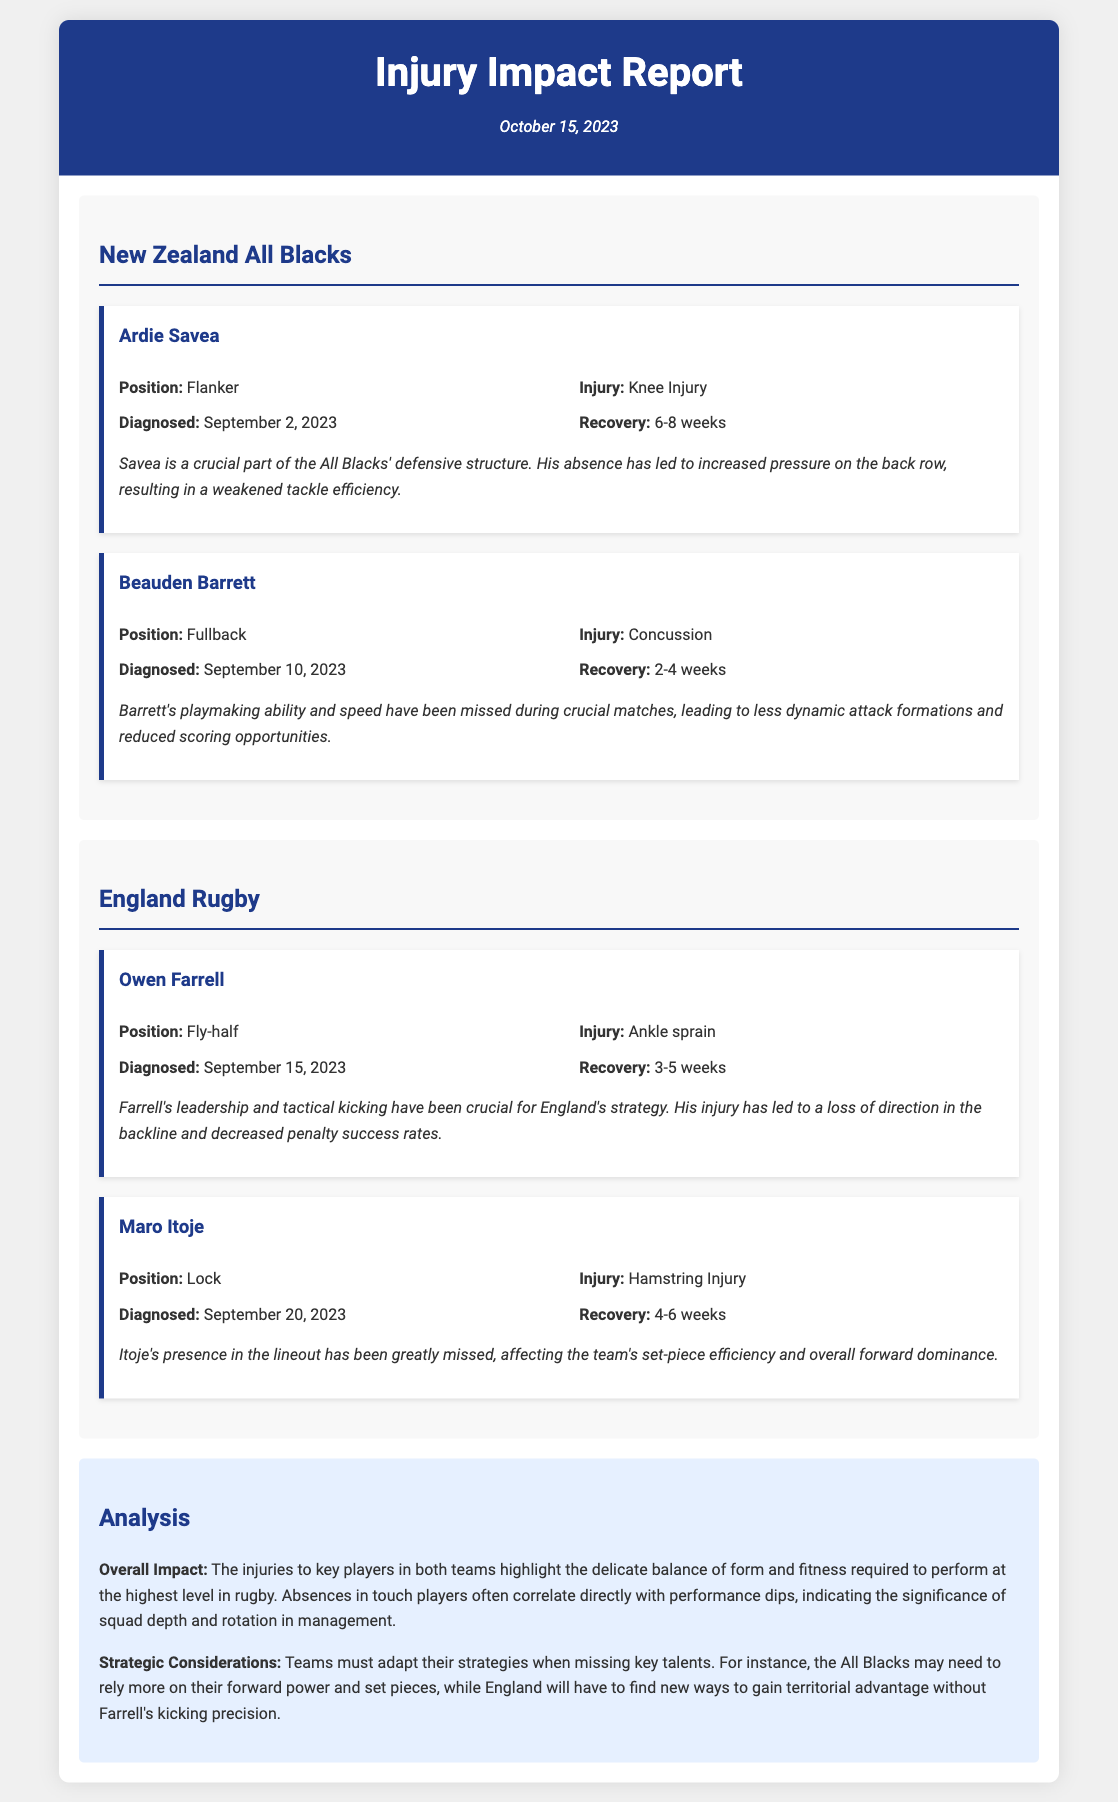What is the title of the report? The title of the report is mentioned at the top of the document, clearly indicating the topic covered.
Answer: Injury Impact Report Who is the player diagnosed with a knee injury? The document lists Ardie Savea as the player who has been diagnosed with a knee injury.
Answer: Ardie Savea What is the recovery timeline for Beauden Barrett? The recovery timeline for Beauden Barrett is specified in the document as a range of time for his concussion injury.
Answer: 2-4 weeks Which team does Owen Farrell play for? The document states that Owen Farrell is part of the England Rugby team, specifying his affiliation.
Answer: England Rugby What injury did Maro Itoje suffer from? The report specifically describes the injury Maro Itoje is dealing with in detail.
Answer: Hamstring Injury What impact has Savea's absence had on the All Blacks? The report discusses the negative effects on the team's performance due to Savea’s absence, particularly in defensive structure.
Answer: Weakened tackle efficiency How long after his diagnosis is Farrell expected to recover? The time from Farrell's diagnosis to recovery can be inferred from the information provided about his injury recovery duration.
Answer: 3-5 weeks What overall conclusion does the analysis section provide? The analysis section summarizes the implications of player injuries on team performance dynamics within rugby.
Answer: Delicate balance of form and fitness Which strategic adjustment might the All Blacks make due to Savea's injury? The document suggests adaptations in strategy which the team may consider as a result of player injuries, relating to their gameplay approach.
Answer: Rely more on forward power and set pieces 